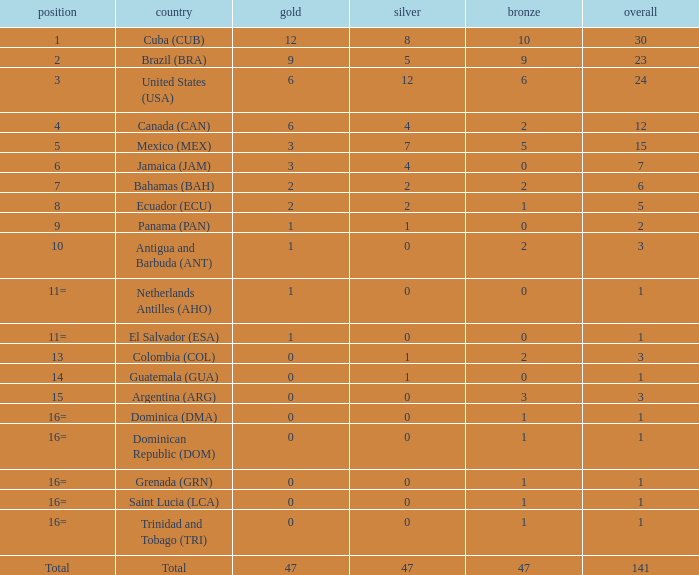How many bronzes have a Nation of jamaica (jam), and a Total smaller than 7? 0.0. Help me parse the entirety of this table. {'header': ['position', 'country', 'gold', 'silver', 'bronze', 'overall'], 'rows': [['1', 'Cuba (CUB)', '12', '8', '10', '30'], ['2', 'Brazil (BRA)', '9', '5', '9', '23'], ['3', 'United States (USA)', '6', '12', '6', '24'], ['4', 'Canada (CAN)', '6', '4', '2', '12'], ['5', 'Mexico (MEX)', '3', '7', '5', '15'], ['6', 'Jamaica (JAM)', '3', '4', '0', '7'], ['7', 'Bahamas (BAH)', '2', '2', '2', '6'], ['8', 'Ecuador (ECU)', '2', '2', '1', '5'], ['9', 'Panama (PAN)', '1', '1', '0', '2'], ['10', 'Antigua and Barbuda (ANT)', '1', '0', '2', '3'], ['11=', 'Netherlands Antilles (AHO)', '1', '0', '0', '1'], ['11=', 'El Salvador (ESA)', '1', '0', '0', '1'], ['13', 'Colombia (COL)', '0', '1', '2', '3'], ['14', 'Guatemala (GUA)', '0', '1', '0', '1'], ['15', 'Argentina (ARG)', '0', '0', '3', '3'], ['16=', 'Dominica (DMA)', '0', '0', '1', '1'], ['16=', 'Dominican Republic (DOM)', '0', '0', '1', '1'], ['16=', 'Grenada (GRN)', '0', '0', '1', '1'], ['16=', 'Saint Lucia (LCA)', '0', '0', '1', '1'], ['16=', 'Trinidad and Tobago (TRI)', '0', '0', '1', '1'], ['Total', 'Total', '47', '47', '47', '141']]} 